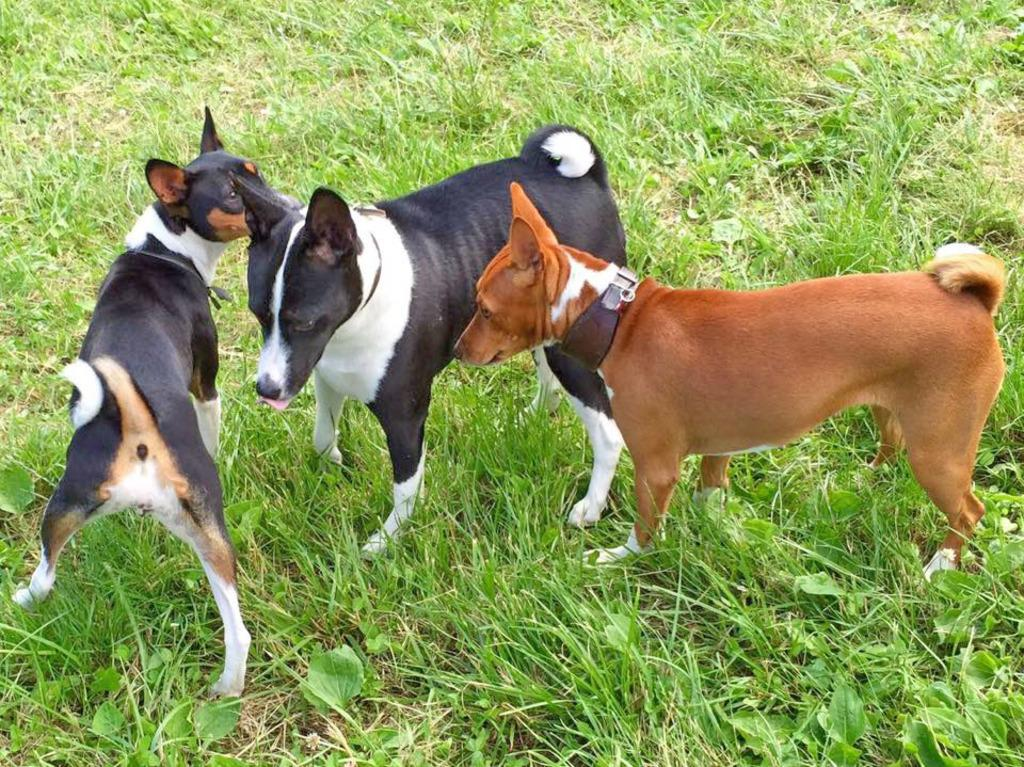What animals are in the center of the image? There are dogs in the center of the image. What type of surface is at the bottom of the image? There is grass at the bottom of the image. What type of leather can be seen in the image? There is no leather present in the image. Is there a river flowing through the image? There is no river present in the image. 